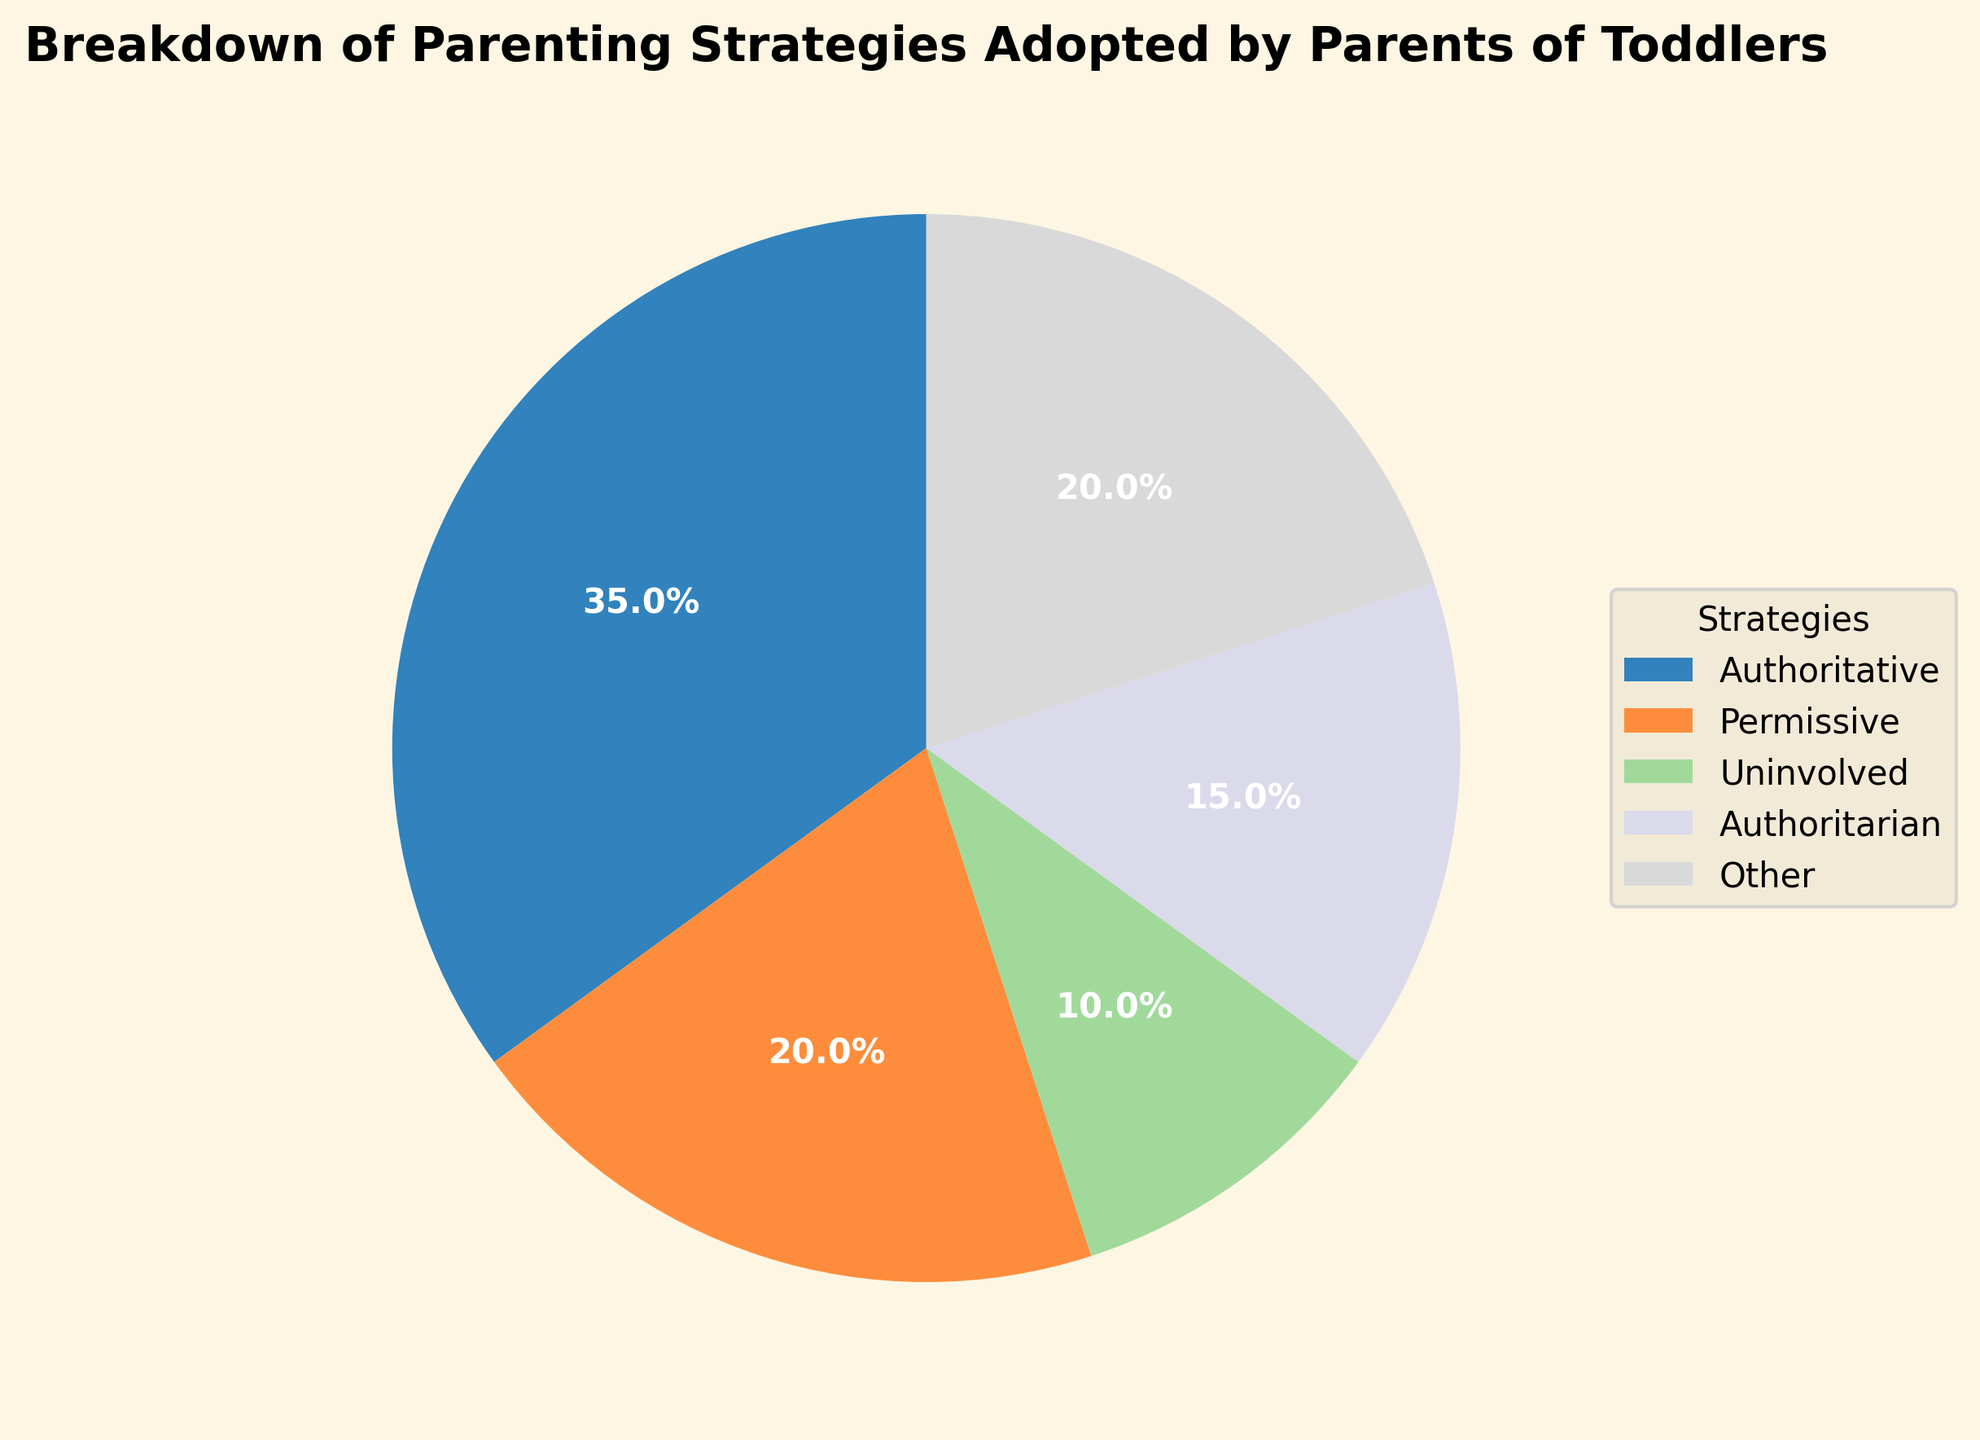What's the most common parenting strategy adopted by parents of toddlers? The figure shows that the 'Authoritative' parenting strategy occupies the largest section of the pie chart, representing 35% of the total.
Answer: Authoritative Which parenting strategy is adopted by the smallest percentage of parents? The 'Uninvolved' parenting strategy occupies the smallest section of the pie chart, representing 10% of the total.
Answer: Uninvolved How does the percentage of parents using the 'Authoritative' strategy compare to those using the 'Authoritarian' strategy? The 'Authoritative' strategy is adopted by 35% of parents, while the 'Authoritarian' strategy is adopted by 15%. Thus, the 'Authoritative' strategy is used by a higher percentage of parents.
Answer: Authoritative What is the combined percentage of parents adopting 'Permissive' and 'Other' strategies? Adding the percentages for 'Permissive' (20%) and 'Other' (20%) gives a combined total of 40%.
Answer: 40% Which two strategies combined have a higher percentage than the 'Authoritative' strategy alone? The combined percentage of 'Permissive' (20%) and 'Other' (20%) is 40%, which is higher than the 'Authoritative' strategy alone at 35%.
Answer: Permissive and Other How many strategies are represented in the pie chart? The pie chart includes five categories: Authoritative, Permissive, Uninvolved, Authoritarian, and Other.
Answer: 5 What percentage is represented by strategies other than 'Authoritative' and 'Uninvolved'? Summing the percentages of 'Permissive' (20%), 'Authoritarian' (15%), and 'Other' (20%) results in 55%.
Answer: 55% If you add the percentage of 'Uninvolved' and 'Authoritarian' strategies, how does that compare to the 'Other' strategy? The sum of 'Uninvolved' (10%) and 'Authoritarian' (15%) is 25%, which is greater than the 'Other' strategy at 20%.
Answer: Greater What is the visual appearance of the 'Permissive' strategy on the pie chart? The 'Permissive' strategy is one of the five colored sections of the pie chart, occupying 20% of the area. Its specific color is visually distinct but not specified in terms of name.
Answer: Occupies 20% Which two strategies have the same percentage representation? 'Permissive' and 'Other' strategies both occupy 20% of the pie chart.
Answer: Permissive and Other 